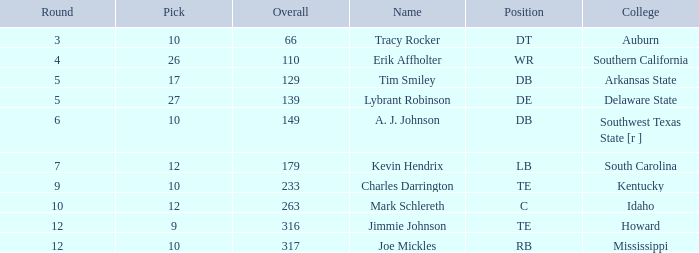What is the aggregate of overall when college is "arkansas state" and pick is lesser than 17? None. 